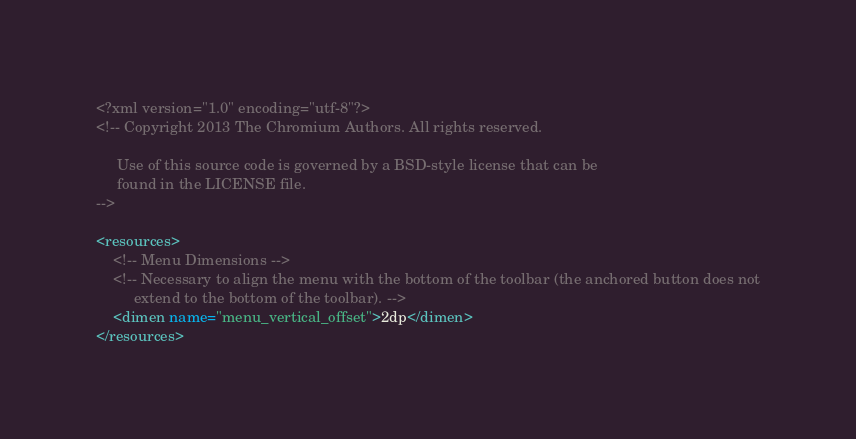<code> <loc_0><loc_0><loc_500><loc_500><_XML_><?xml version="1.0" encoding="utf-8"?>
<!-- Copyright 2013 The Chromium Authors. All rights reserved.

     Use of this source code is governed by a BSD-style license that can be
     found in the LICENSE file.
-->

<resources>
    <!-- Menu Dimensions -->
    <!-- Necessary to align the menu with the bottom of the toolbar (the anchored button does not
         extend to the bottom of the toolbar). -->
    <dimen name="menu_vertical_offset">2dp</dimen>
</resources>
</code> 